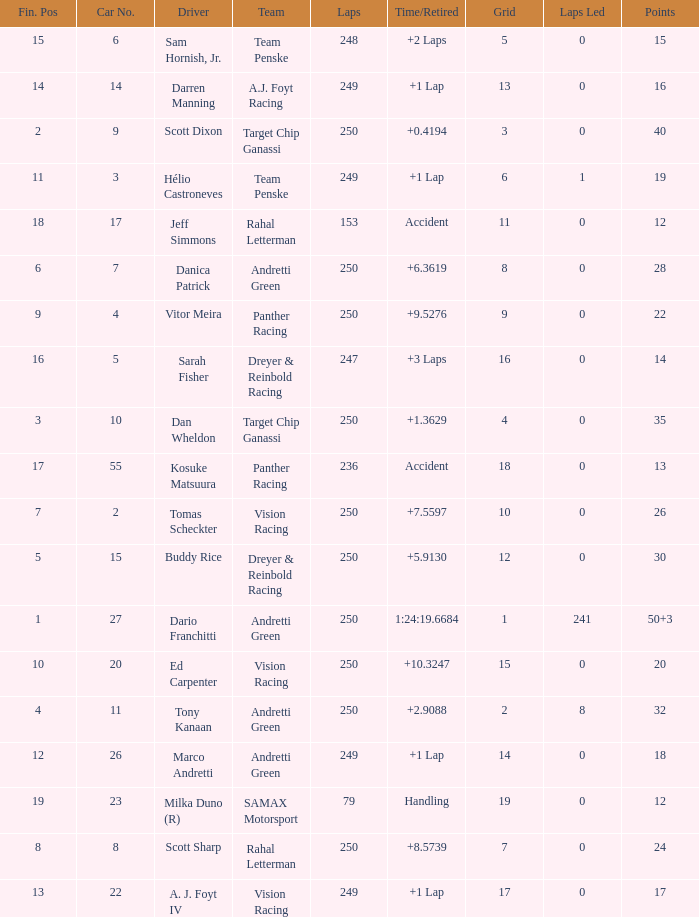Name the least grid for 17 points  17.0. 